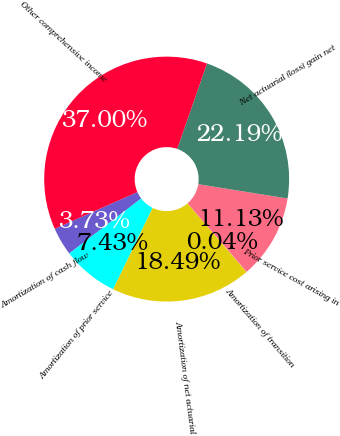Convert chart. <chart><loc_0><loc_0><loc_500><loc_500><pie_chart><fcel>Amortization of cash flow<fcel>Amortization of prior service<fcel>Amortization of net actuarial<fcel>Amortization of transition<fcel>Prior service cost arising in<fcel>Net actuarial (loss) gain net<fcel>Other comprehensive income<nl><fcel>3.73%<fcel>7.43%<fcel>18.49%<fcel>0.04%<fcel>11.13%<fcel>22.19%<fcel>37.0%<nl></chart> 